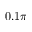<formula> <loc_0><loc_0><loc_500><loc_500>0 . 1 \pi</formula> 